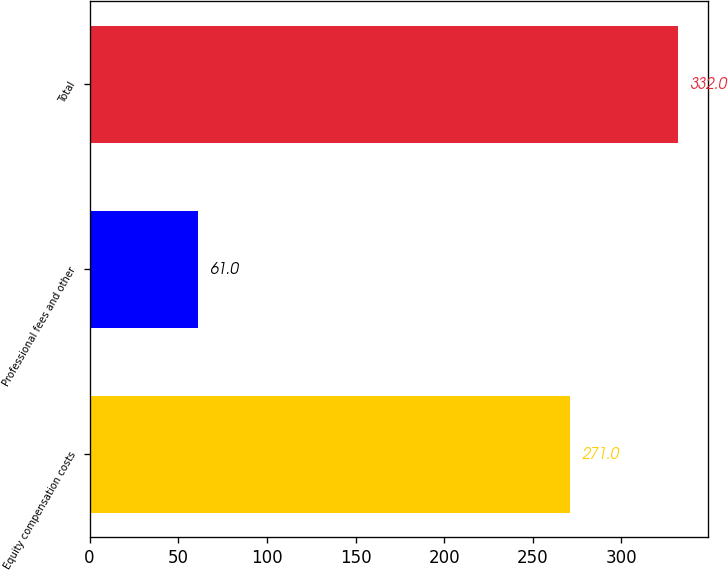<chart> <loc_0><loc_0><loc_500><loc_500><bar_chart><fcel>Equity compensation costs<fcel>Professional fees and other<fcel>Total<nl><fcel>271<fcel>61<fcel>332<nl></chart> 